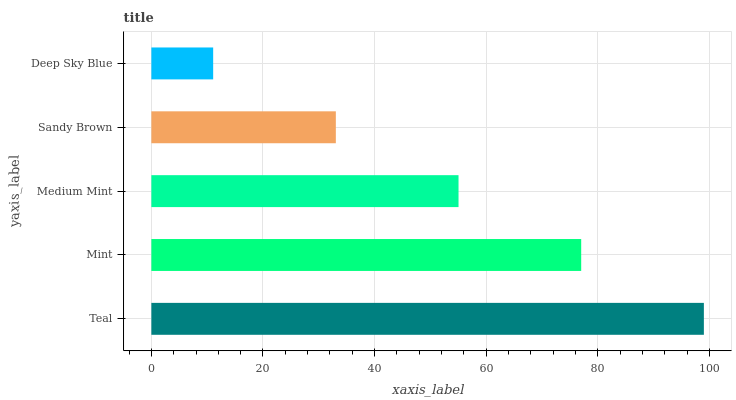Is Deep Sky Blue the minimum?
Answer yes or no. Yes. Is Teal the maximum?
Answer yes or no. Yes. Is Mint the minimum?
Answer yes or no. No. Is Mint the maximum?
Answer yes or no. No. Is Teal greater than Mint?
Answer yes or no. Yes. Is Mint less than Teal?
Answer yes or no. Yes. Is Mint greater than Teal?
Answer yes or no. No. Is Teal less than Mint?
Answer yes or no. No. Is Medium Mint the high median?
Answer yes or no. Yes. Is Medium Mint the low median?
Answer yes or no. Yes. Is Teal the high median?
Answer yes or no. No. Is Deep Sky Blue the low median?
Answer yes or no. No. 